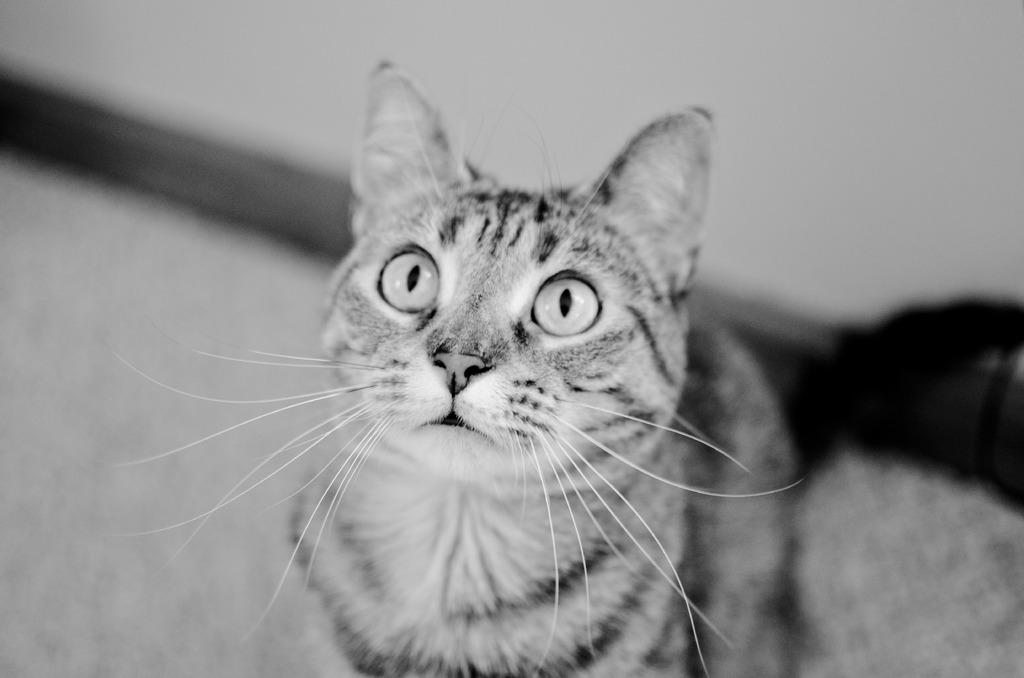What is the main subject in the center of the image? There is a cat in the center of the image. What type of structure is visible at the top of the image? There is a wall at the top of the image. What surface is visible on the left side of the image? There is a floor on the left side of the image. What color is the paint on the cat's fur in the image? There is no mention of paint or any color on the cat's fur in the image. 